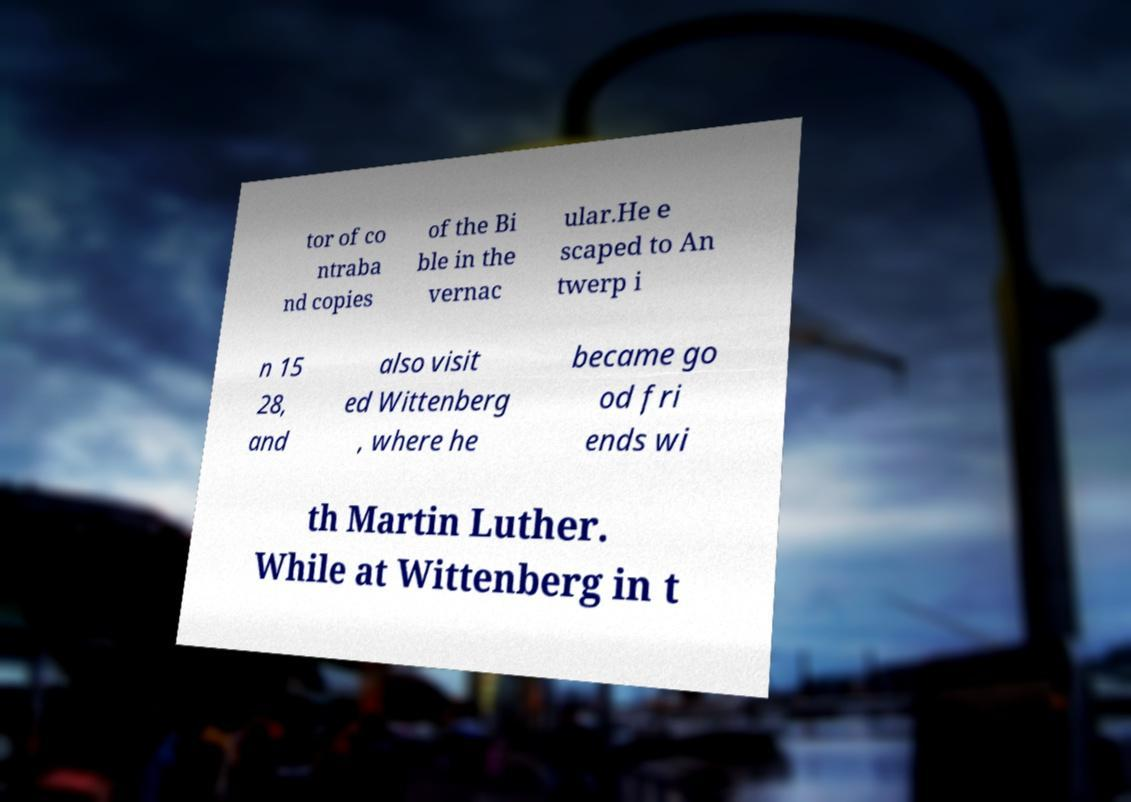Can you accurately transcribe the text from the provided image for me? tor of co ntraba nd copies of the Bi ble in the vernac ular.He e scaped to An twerp i n 15 28, and also visit ed Wittenberg , where he became go od fri ends wi th Martin Luther. While at Wittenberg in t 